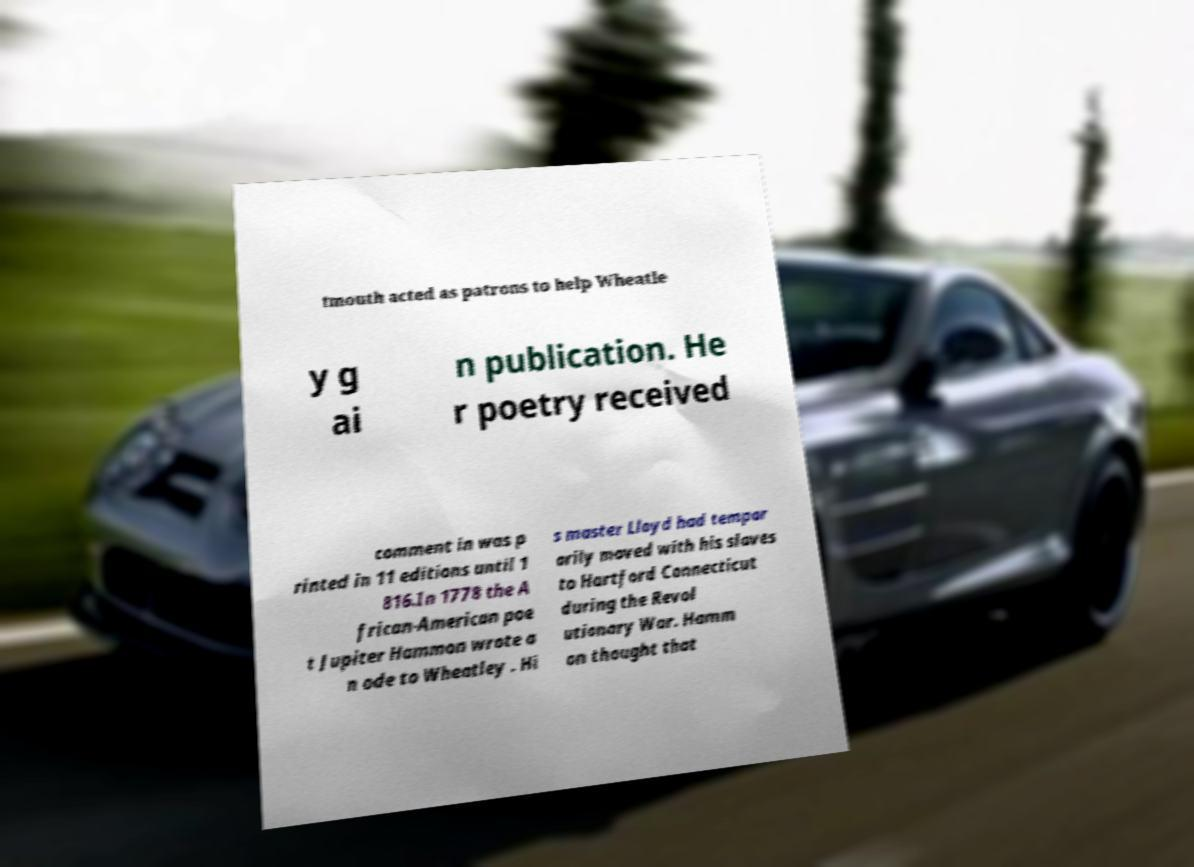What messages or text are displayed in this image? I need them in a readable, typed format. tmouth acted as patrons to help Wheatle y g ai n publication. He r poetry received comment in was p rinted in 11 editions until 1 816.In 1778 the A frican-American poe t Jupiter Hammon wrote a n ode to Wheatley . Hi s master Lloyd had tempor arily moved with his slaves to Hartford Connecticut during the Revol utionary War. Hamm on thought that 